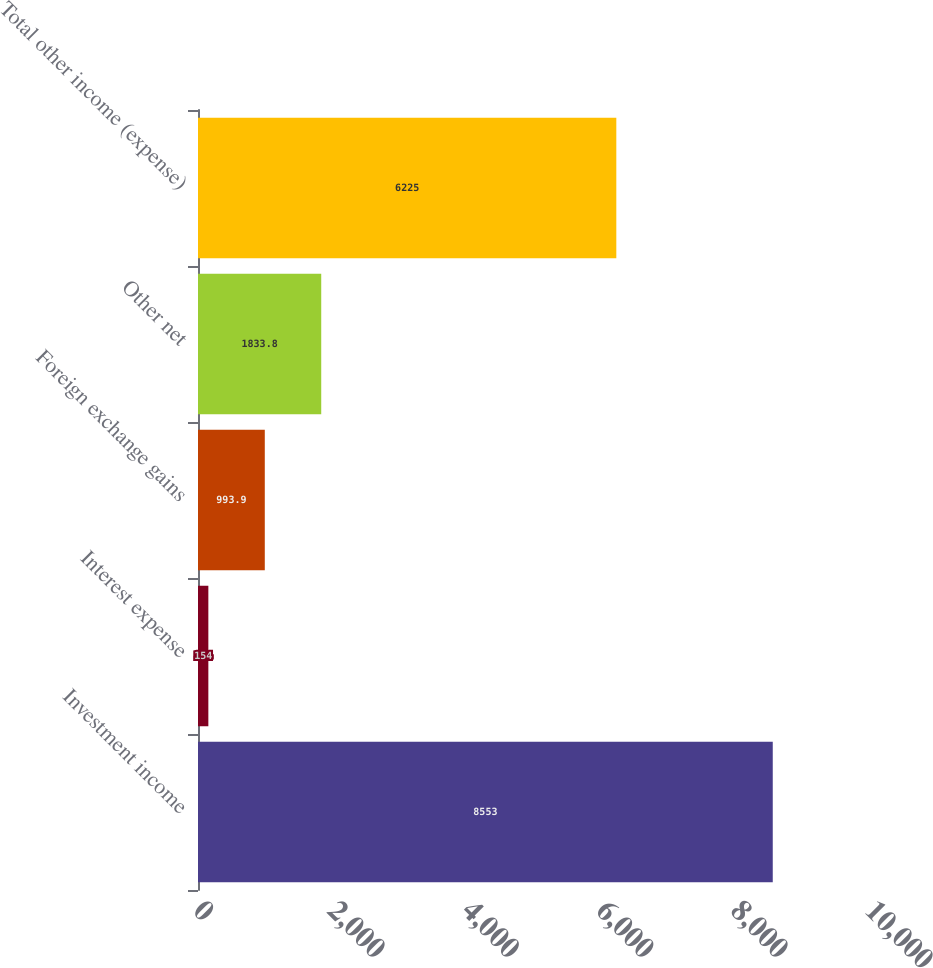<chart> <loc_0><loc_0><loc_500><loc_500><bar_chart><fcel>Investment income<fcel>Interest expense<fcel>Foreign exchange gains<fcel>Other net<fcel>Total other income (expense)<nl><fcel>8553<fcel>154<fcel>993.9<fcel>1833.8<fcel>6225<nl></chart> 